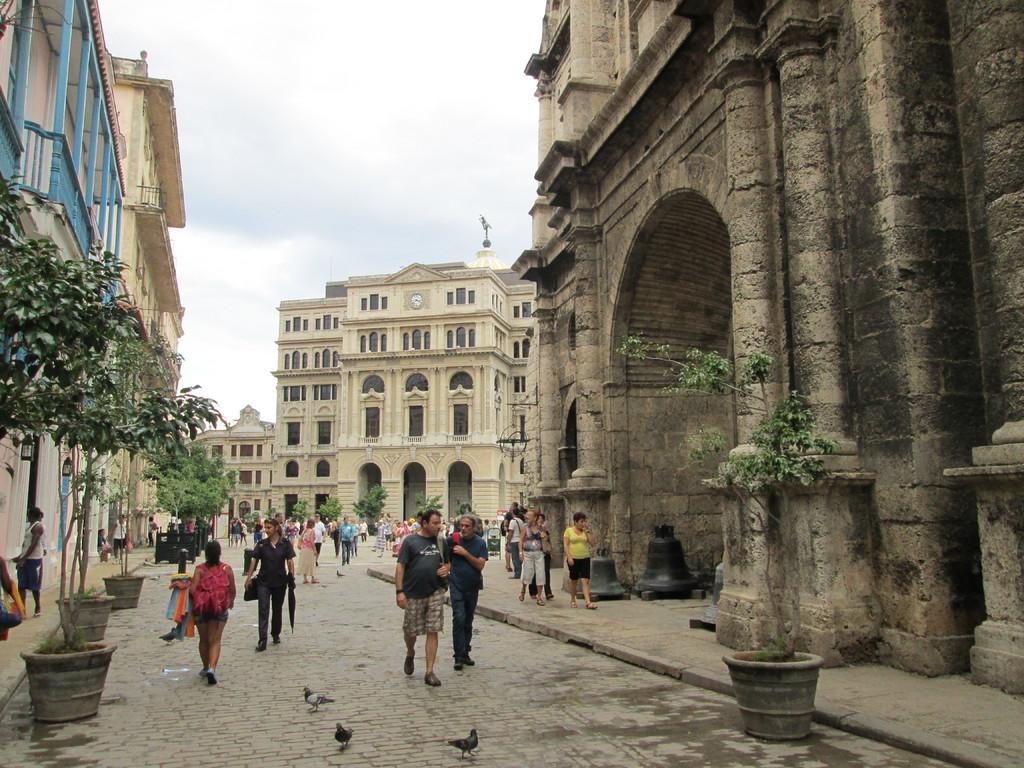Please provide a concise description of this image. In this image we can see people are walking on the road and pavement. On the both sides of the image, we can see buildings and potted plants. At the bottom of the image, we can see three birds. We can see buildings in the middle of the image. At the top of the image, the sky is covered with clouds. 